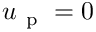<formula> <loc_0><loc_0><loc_500><loc_500>u _ { p } = 0</formula> 